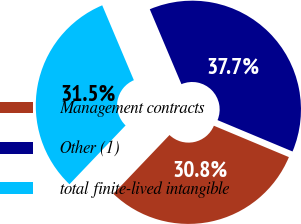Convert chart to OTSL. <chart><loc_0><loc_0><loc_500><loc_500><pie_chart><fcel>Management contracts<fcel>Other (1)<fcel>total finite-lived intangible<nl><fcel>30.82%<fcel>37.67%<fcel>31.51%<nl></chart> 